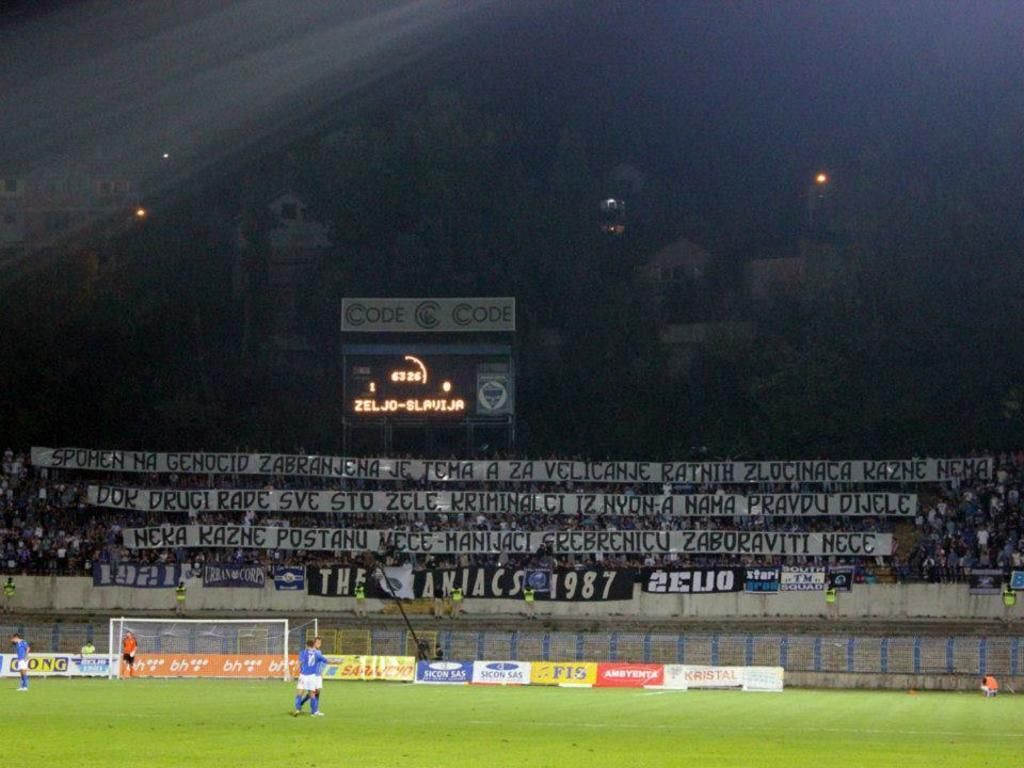What type of structure is the main subject of the image? There is a stadium in the image. What can be seen on the ground near the stadium? There are persons standing on the ground. What activity is likely taking place in the image? There is a sportsnet in the image, suggesting a sports event is happening. Are there any commercial elements in the image? Yes, advertisements are present in the image. Who might be watching the event taking place in the image? There are spectators in the image. What technology is visible in the image? A display screen is visible in the image. What other structures can be seen in the image? There are buildings in the image. What type of lighting is present in the image? Electric lights are present in the image. What type of industry is depicted in the image? There is no specific industry depicted in the image; it primarily features a stadium and related activities. Is there a crib visible in the image? No, there is no crib present in the image. 